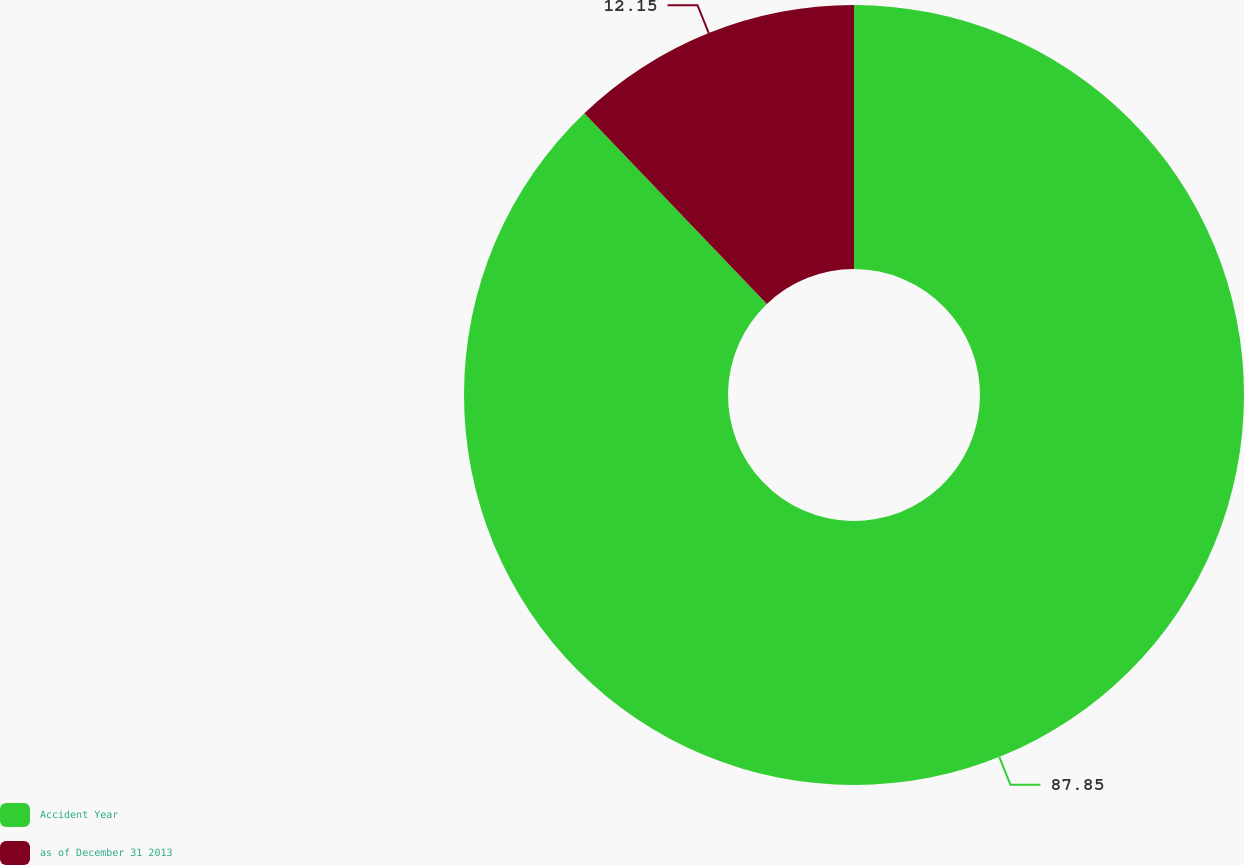<chart> <loc_0><loc_0><loc_500><loc_500><pie_chart><fcel>Accident Year<fcel>as of December 31 2013<nl><fcel>87.85%<fcel>12.15%<nl></chart> 